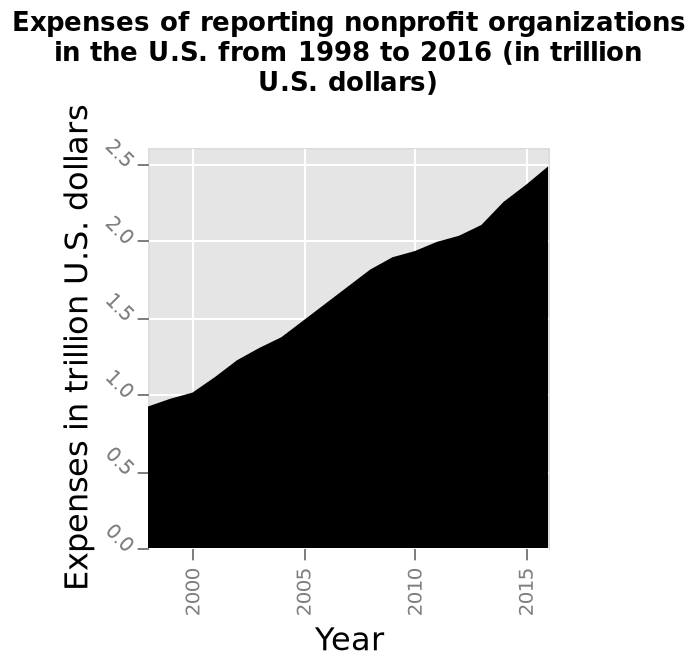<image>
What is the range of the y-axis? The y-axis represents expenses in trillion U.S. dollars, ranging from 0.0 to 2.5. How many reporting nonprofit organizations are included in the graph? The description does not provide information about the number of reporting nonprofit organizations included in the graph. Which year had higher expenses for reporting non-profit organisations? The year 2015 had higher expenses for reporting non-profit organisations compared to 2000. please summary the statistics and relations of the chart The chart shows a gradual increase in expenses between 1998 and 2016. Did the year 2000 have higher expenses for reporting non-profit organisations compared to 2015? No.The year 2015 had higher expenses for reporting non-profit organisations compared to 2000. 